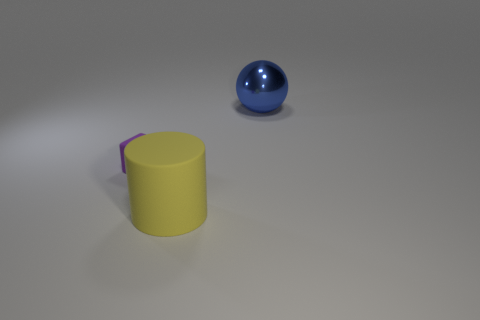Add 1 yellow matte cylinders. How many objects exist? 4 Subtract all spheres. How many objects are left? 2 Add 2 blue metal objects. How many blue metal objects are left? 3 Add 3 green metal balls. How many green metal balls exist? 3 Subtract 0 yellow spheres. How many objects are left? 3 Subtract all matte cylinders. Subtract all big yellow cylinders. How many objects are left? 1 